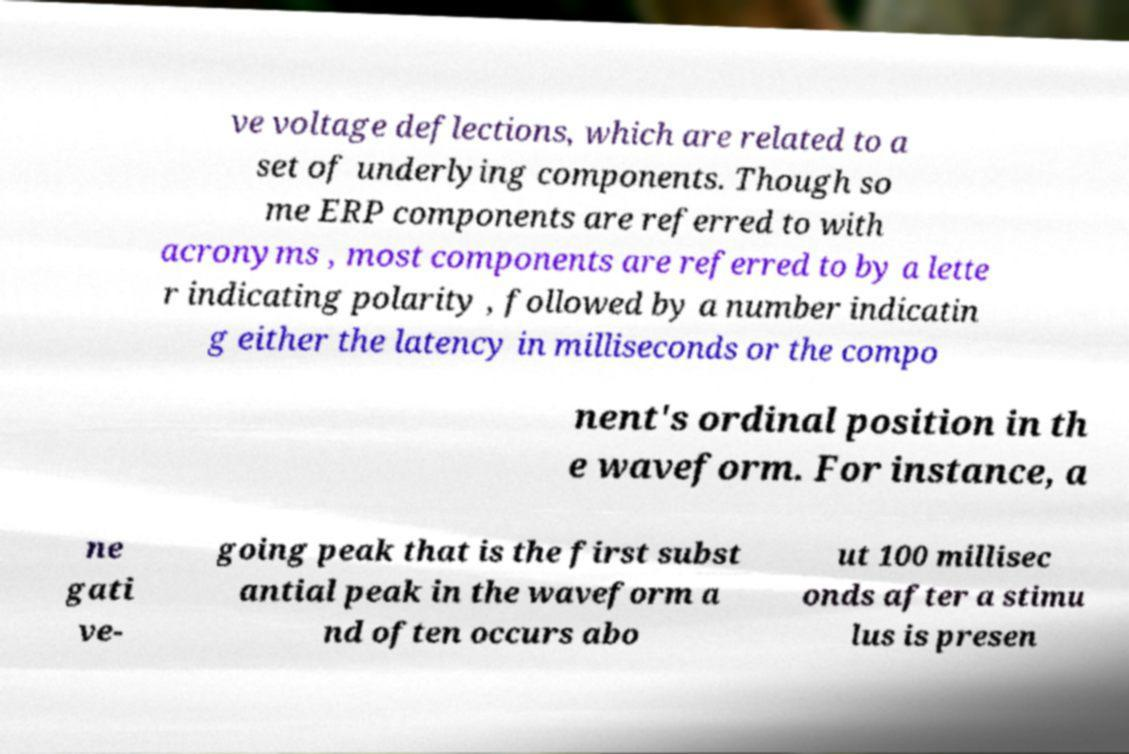What messages or text are displayed in this image? I need them in a readable, typed format. ve voltage deflections, which are related to a set of underlying components. Though so me ERP components are referred to with acronyms , most components are referred to by a lette r indicating polarity , followed by a number indicatin g either the latency in milliseconds or the compo nent's ordinal position in th e waveform. For instance, a ne gati ve- going peak that is the first subst antial peak in the waveform a nd often occurs abo ut 100 millisec onds after a stimu lus is presen 